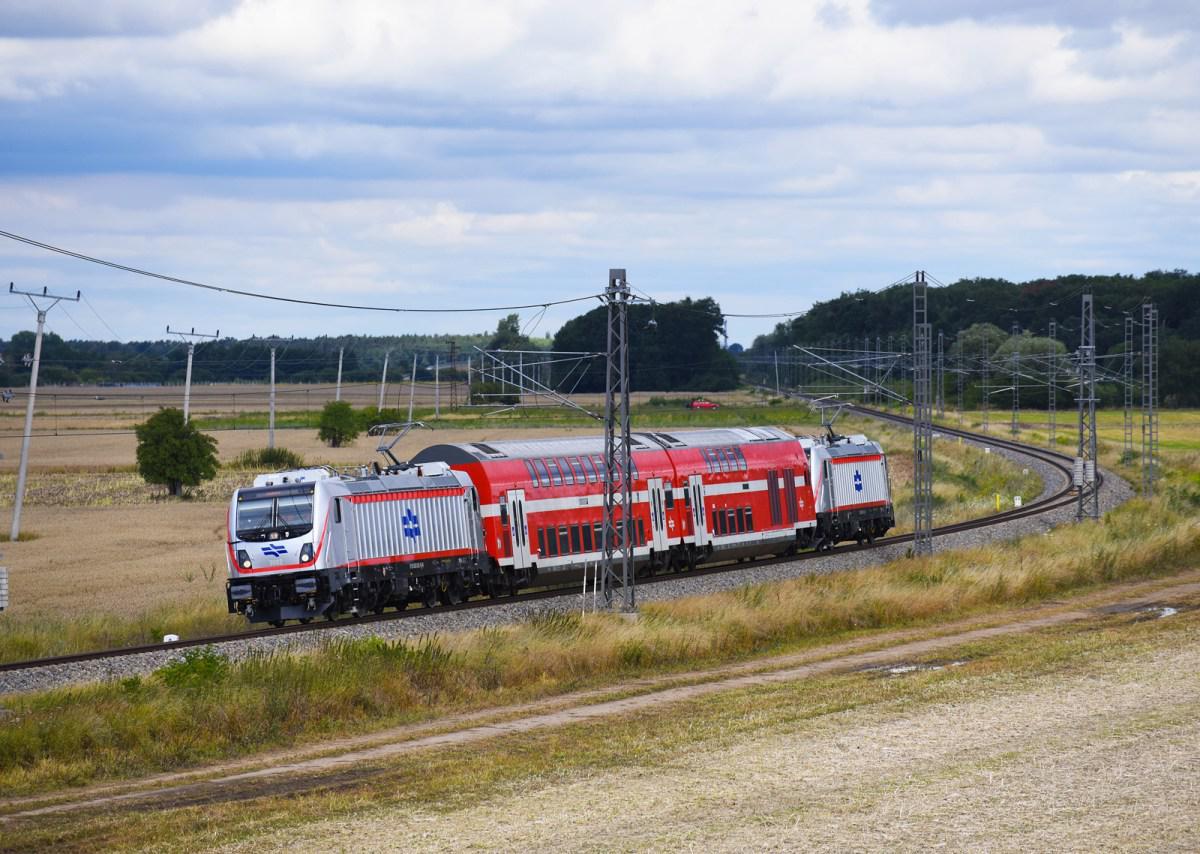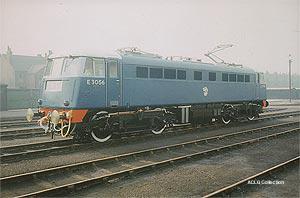The first image is the image on the left, the second image is the image on the right. Analyze the images presented: Is the assertion "An image shows a train with a yellow front and a red side stripe, angled heading leftward." valid? Answer yes or no. No. The first image is the image on the left, the second image is the image on the right. Considering the images on both sides, is "The train in one of the images has just come around a bend." valid? Answer yes or no. Yes. The first image is the image on the left, the second image is the image on the right. Evaluate the accuracy of this statement regarding the images: "The train in the right image is painted yellow in the front.". Is it true? Answer yes or no. No. The first image is the image on the left, the second image is the image on the right. Analyze the images presented: Is the assertion "The area on the front bottom of the train in the image on the left is yellow." valid? Answer yes or no. No. 